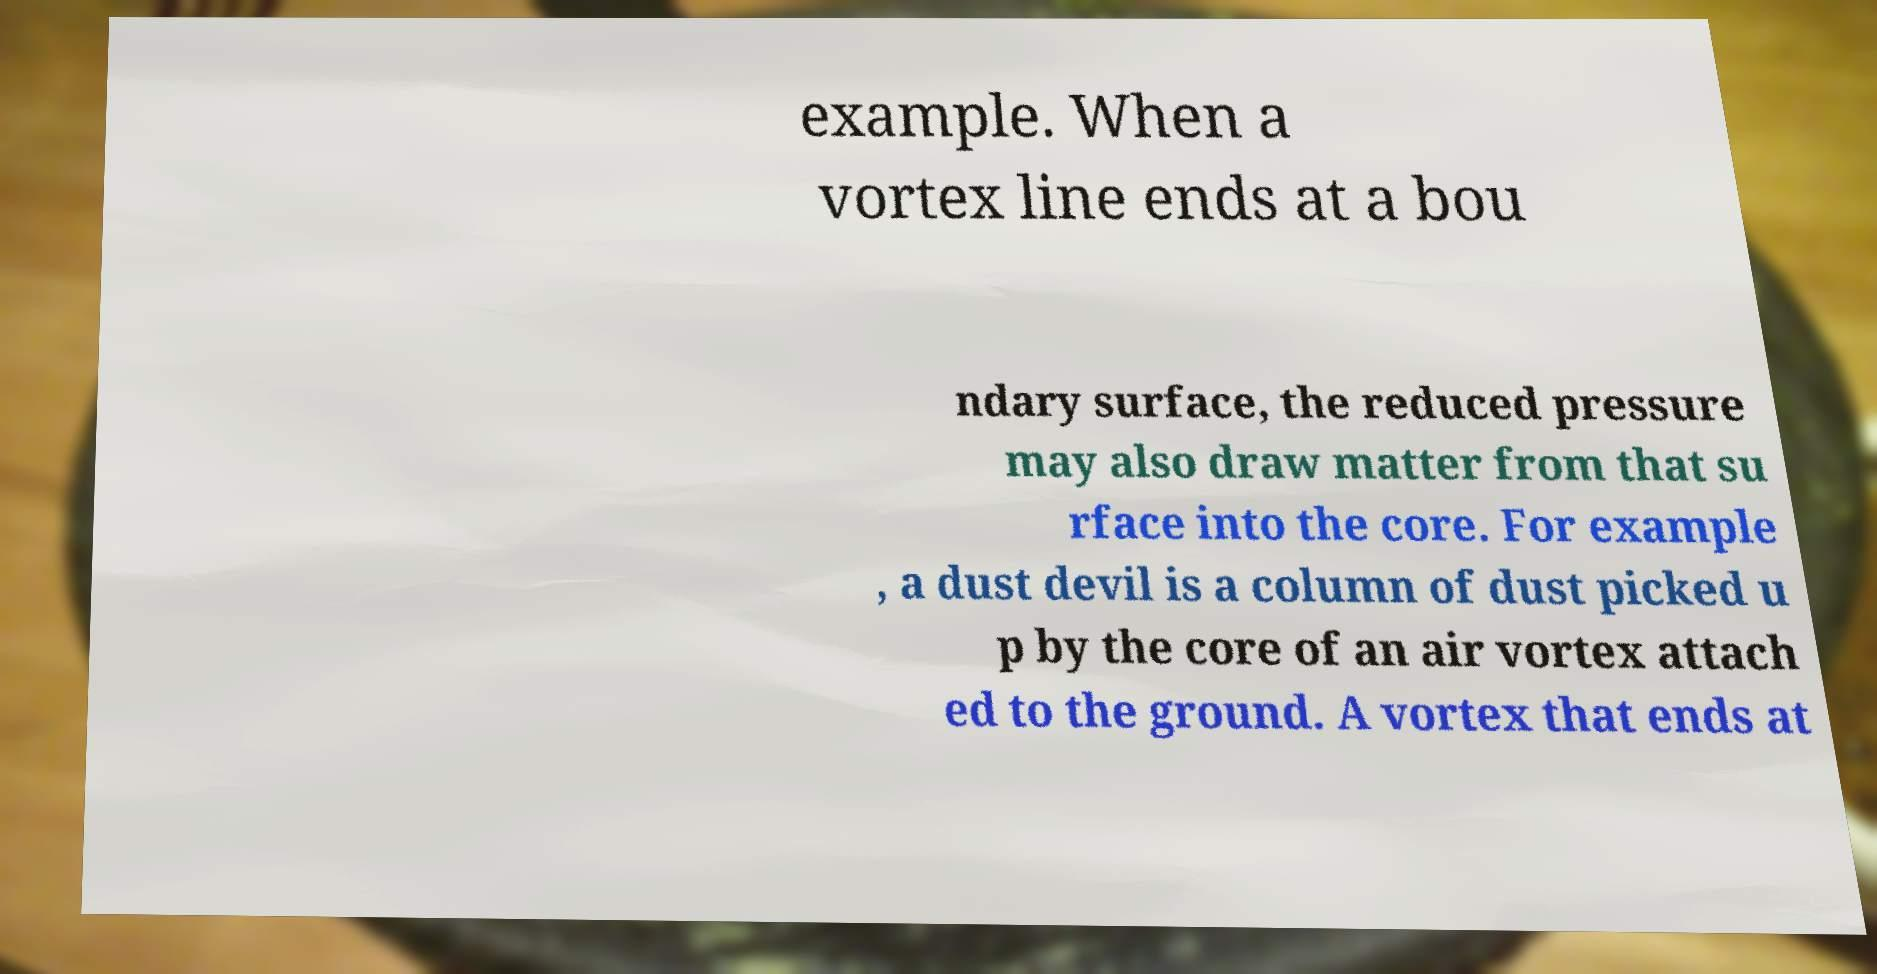Could you assist in decoding the text presented in this image and type it out clearly? example. When a vortex line ends at a bou ndary surface, the reduced pressure may also draw matter from that su rface into the core. For example , a dust devil is a column of dust picked u p by the core of an air vortex attach ed to the ground. A vortex that ends at 